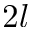<formula> <loc_0><loc_0><loc_500><loc_500>2 l</formula> 